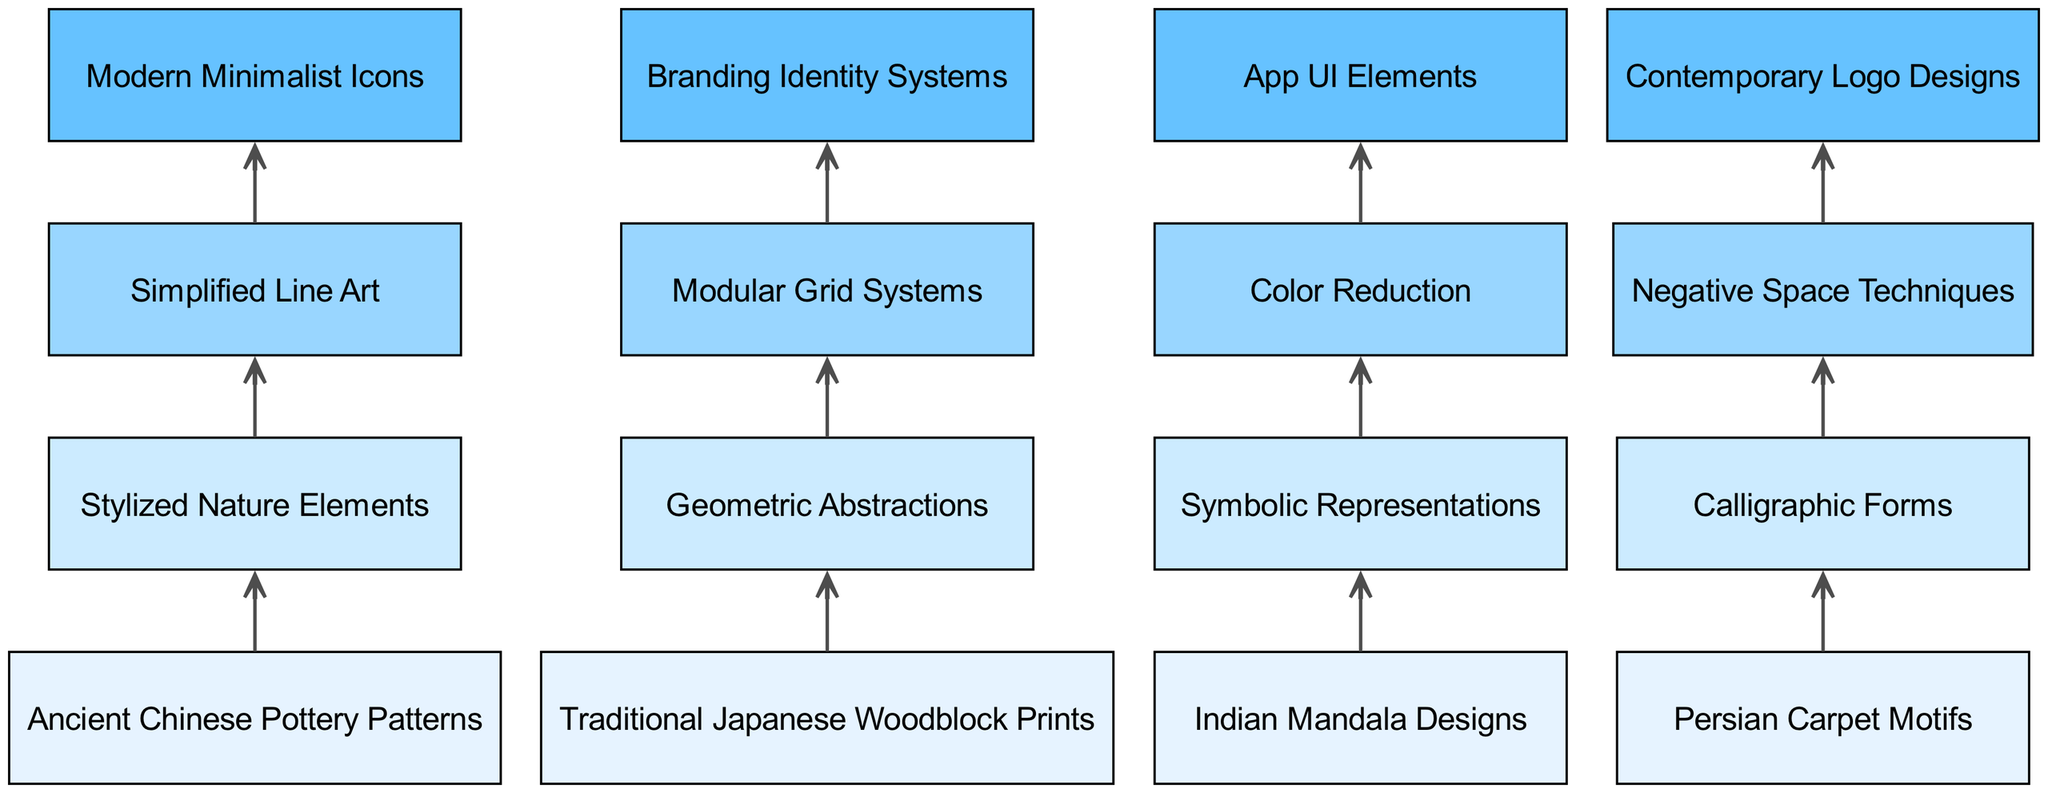What are the base elements in this diagram? The diagram includes four base elements: Ancient Chinese Pottery Patterns, Traditional Japanese Woodblock Prints, Indian Mandala Designs, and Persian Carpet Motifs.
Answer: Ancient Chinese Pottery Patterns, Traditional Japanese Woodblock Prints, Indian Mandala Designs, Persian Carpet Motifs How many advanced elements are there? The diagram shows four advanced elements: Simplified Line Art, Negative Space Techniques, Color Reduction, and Modular Grid Systems. Since there are four items listed under advanced elements, the count is 4.
Answer: 4 What connects Traditional Japanese Woodblock Prints to Geometric Abstractions? The diagram has an arrow connecting Traditional Japanese Woodblock Prints to Geometric Abstractions, indicating a direct relationship and flow between these two elements.
Answer: Geometric Abstractions Which top element is connected to Simplified Line Art? The diagram shows that Simplified Line Art flows into Modern Minimalist Icons, revealing that it is one of the top elements directly connected to this advanced element.
Answer: Modern Minimalist Icons What is the final top element in the flow from Color Reduction? The flow from Color Reduction results in App UI Elements, indicating that this top element is the outcome of this advanced element.
Answer: App UI Elements What is the connection from Persian Carpet Motifs? The connection from Persian Carpet Motifs leads to Calligraphic Forms, illustrating that it is an intermediate element in the journey towards more modern design forms.
Answer: Calligraphic Forms Are there more advanced elements than intermediate elements? There are four advanced elements and four intermediate elements, so they are equal in number, not more.
Answer: No Which element flows into Branding Identity Systems? Modular Grid Systems flows into Branding Identity Systems, marking it as a contributing advanced element in the modern branding hierarchy.
Answer: Modular Grid Systems What is the type of flow represented in this diagram? The diagram represents a Bottom Up Flow Chart, demonstrating how elements progress from ancient to modern forms through various stages.
Answer: Bottom Up Flow Chart 